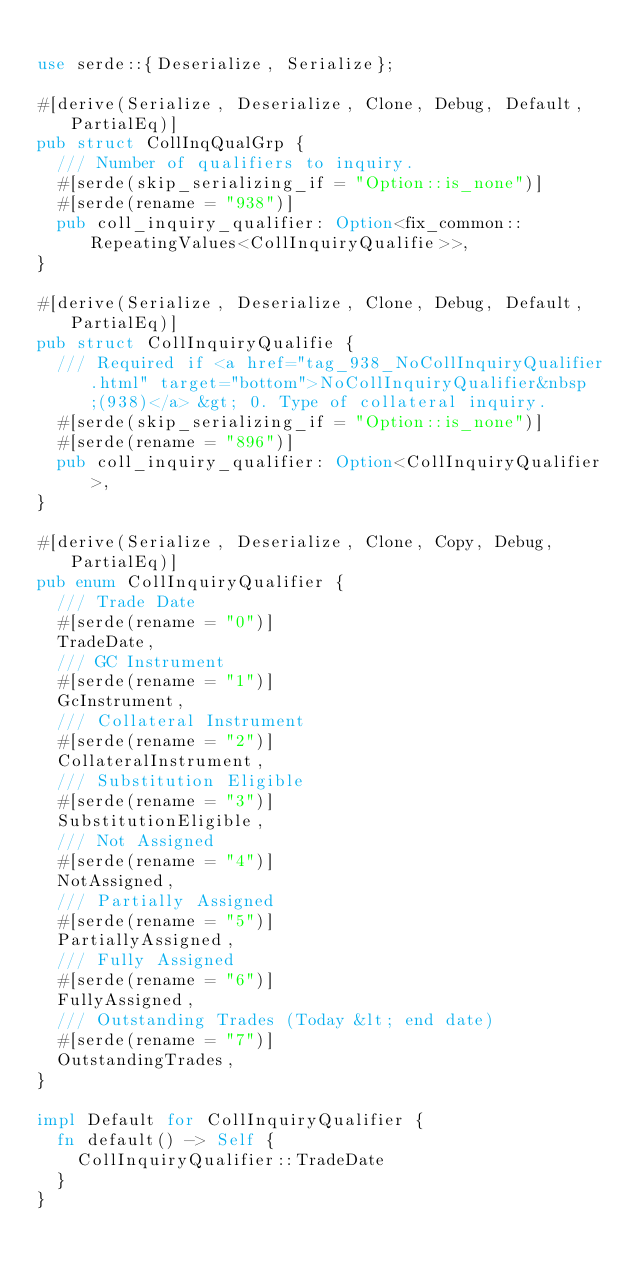Convert code to text. <code><loc_0><loc_0><loc_500><loc_500><_Rust_>
use serde::{Deserialize, Serialize};

#[derive(Serialize, Deserialize, Clone, Debug, Default, PartialEq)]
pub struct CollInqQualGrp {
	/// Number of qualifiers to inquiry.
	#[serde(skip_serializing_if = "Option::is_none")]
	#[serde(rename = "938")]
	pub coll_inquiry_qualifier: Option<fix_common::RepeatingValues<CollInquiryQualifie>>,
}

#[derive(Serialize, Deserialize, Clone, Debug, Default, PartialEq)]
pub struct CollInquiryQualifie {
	/// Required if <a href="tag_938_NoCollInquiryQualifier.html" target="bottom">NoCollInquiryQualifier&nbsp;(938)</a> &gt; 0. Type of collateral inquiry.
	#[serde(skip_serializing_if = "Option::is_none")]
	#[serde(rename = "896")]
	pub coll_inquiry_qualifier: Option<CollInquiryQualifier>,
}

#[derive(Serialize, Deserialize, Clone, Copy, Debug, PartialEq)]
pub enum CollInquiryQualifier {
	/// Trade Date
	#[serde(rename = "0")]
	TradeDate,
	/// GC Instrument
	#[serde(rename = "1")]
	GcInstrument,
	/// Collateral Instrument
	#[serde(rename = "2")]
	CollateralInstrument,
	/// Substitution Eligible
	#[serde(rename = "3")]
	SubstitutionEligible,
	/// Not Assigned
	#[serde(rename = "4")]
	NotAssigned,
	/// Partially Assigned
	#[serde(rename = "5")]
	PartiallyAssigned,
	/// Fully Assigned
	#[serde(rename = "6")]
	FullyAssigned,
	/// Outstanding Trades (Today &lt; end date)
	#[serde(rename = "7")]
	OutstandingTrades,
}

impl Default for CollInquiryQualifier {
	fn default() -> Self {
		CollInquiryQualifier::TradeDate
	}
}
</code> 